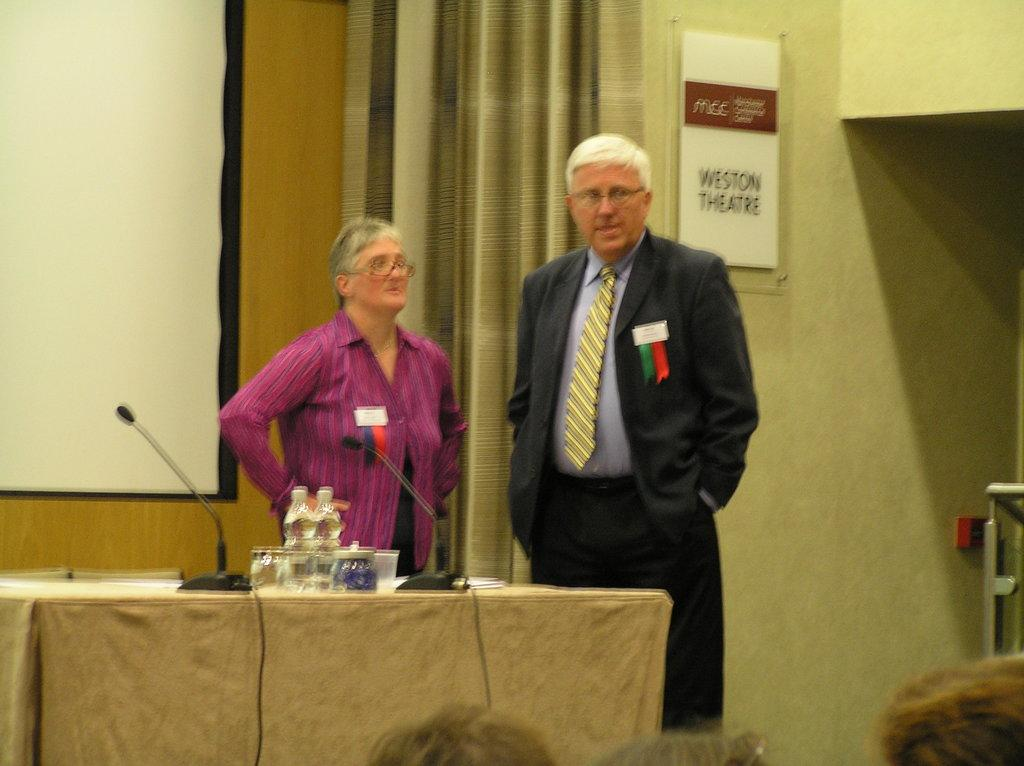How many people are in the image? There are two people in the image. What are the people doing in the image? The people are standing in front of a table. What items can be seen on the table? There are bottles and microphones on the table. What is located beside the table? There is a note beside the table. What is visible behind the people? There is a screen behind the people. How many giraffes are standing behind the people in the image? There are no giraffes present in the image. What type of umbrella is being used by the people in the image? There is no umbrella present in the image. 